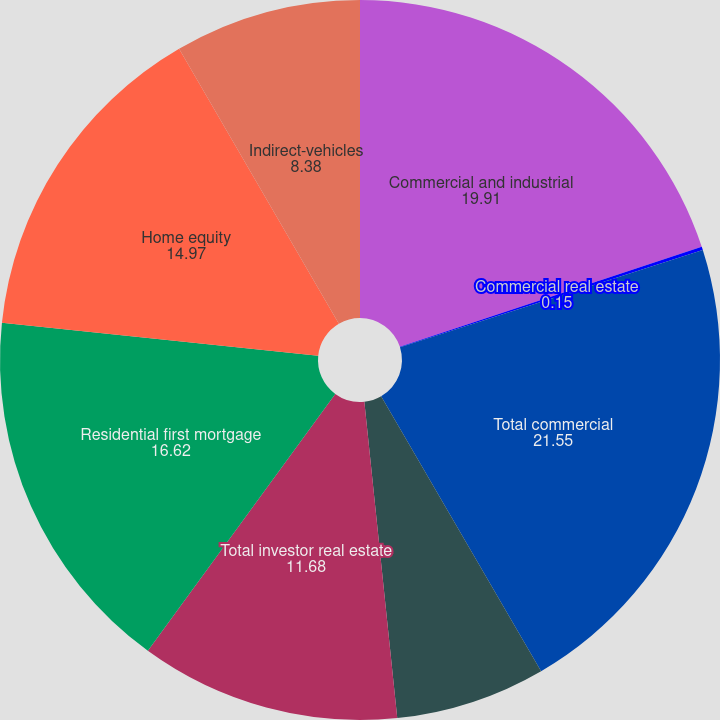Convert chart. <chart><loc_0><loc_0><loc_500><loc_500><pie_chart><fcel>Commercial and industrial<fcel>Commercial real estate<fcel>Total commercial<fcel>Commercial investor real<fcel>Total investor real estate<fcel>Residential first mortgage<fcel>Home equity<fcel>Indirect-vehicles<nl><fcel>19.91%<fcel>0.15%<fcel>21.55%<fcel>6.74%<fcel>11.68%<fcel>16.62%<fcel>14.97%<fcel>8.38%<nl></chart> 